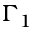<formula> <loc_0><loc_0><loc_500><loc_500>\Gamma _ { 1 }</formula> 